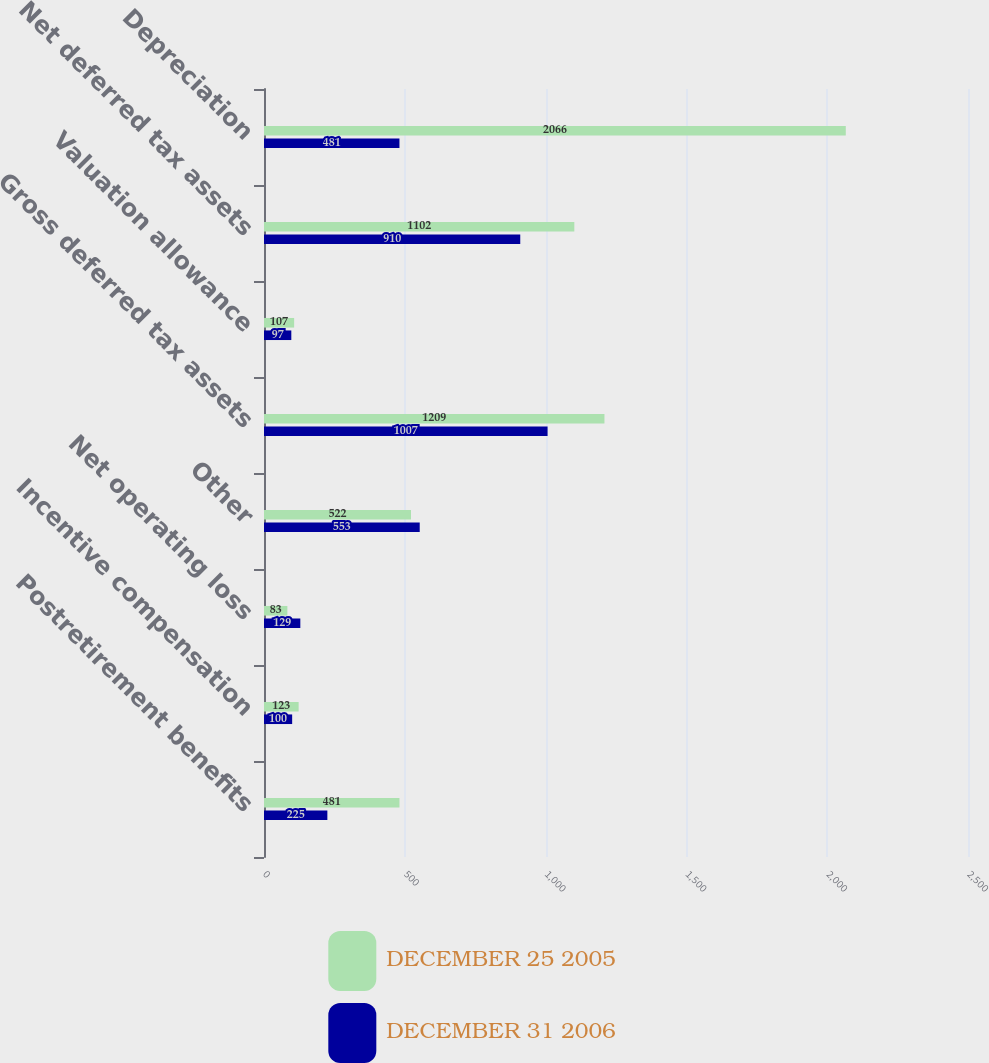<chart> <loc_0><loc_0><loc_500><loc_500><stacked_bar_chart><ecel><fcel>Postretirement benefits<fcel>Incentive compensation<fcel>Net operating loss<fcel>Other<fcel>Gross deferred tax assets<fcel>Valuation allowance<fcel>Net deferred tax assets<fcel>Depreciation<nl><fcel>DECEMBER 25 2005<fcel>481<fcel>123<fcel>83<fcel>522<fcel>1209<fcel>107<fcel>1102<fcel>2066<nl><fcel>DECEMBER 31 2006<fcel>225<fcel>100<fcel>129<fcel>553<fcel>1007<fcel>97<fcel>910<fcel>481<nl></chart> 